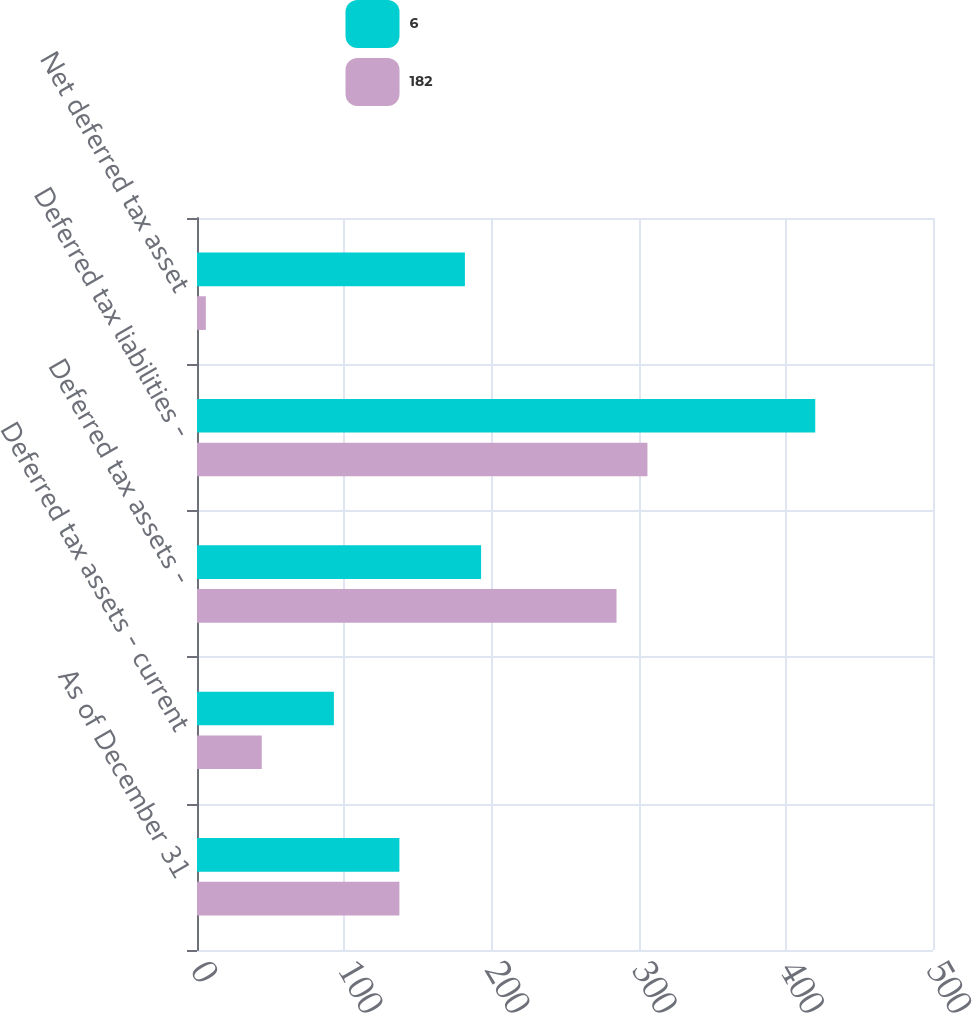Convert chart. <chart><loc_0><loc_0><loc_500><loc_500><stacked_bar_chart><ecel><fcel>As of December 31<fcel>Deferred tax assets - current<fcel>Deferred tax assets -<fcel>Deferred tax liabilities -<fcel>Net deferred tax asset<nl><fcel>6<fcel>137.5<fcel>93<fcel>193<fcel>420<fcel>182<nl><fcel>182<fcel>137.5<fcel>44<fcel>285<fcel>306<fcel>6<nl></chart> 